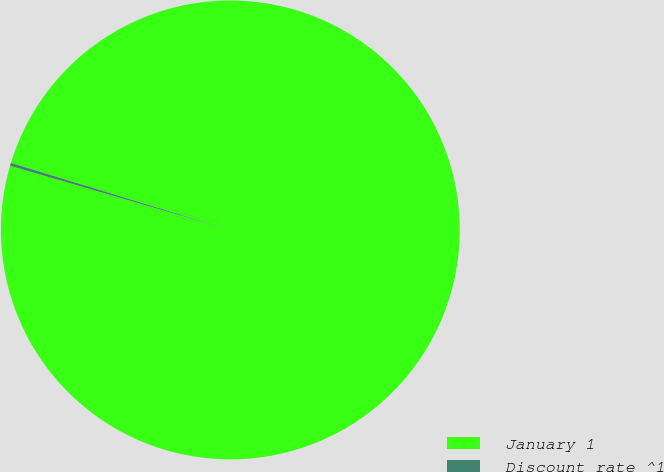Convert chart. <chart><loc_0><loc_0><loc_500><loc_500><pie_chart><fcel>January 1<fcel>Discount rate ^1<nl><fcel>99.79%<fcel>0.21%<nl></chart> 